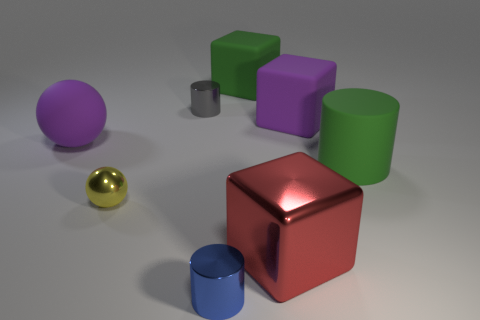Add 2 large green cylinders. How many objects exist? 10 Subtract all balls. How many objects are left? 6 Add 6 gray cylinders. How many gray cylinders are left? 7 Add 7 large cyan shiny things. How many large cyan shiny things exist? 7 Subtract 0 cyan cylinders. How many objects are left? 8 Subtract all red metal blocks. Subtract all purple cubes. How many objects are left? 6 